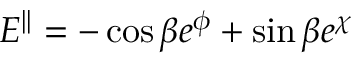Convert formula to latex. <formula><loc_0><loc_0><loc_500><loc_500>E ^ { | | } = - \cos \beta e ^ { \phi } + \sin \beta e ^ { \chi }</formula> 